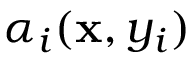<formula> <loc_0><loc_0><loc_500><loc_500>\alpha _ { i } ( x , y _ { i } )</formula> 